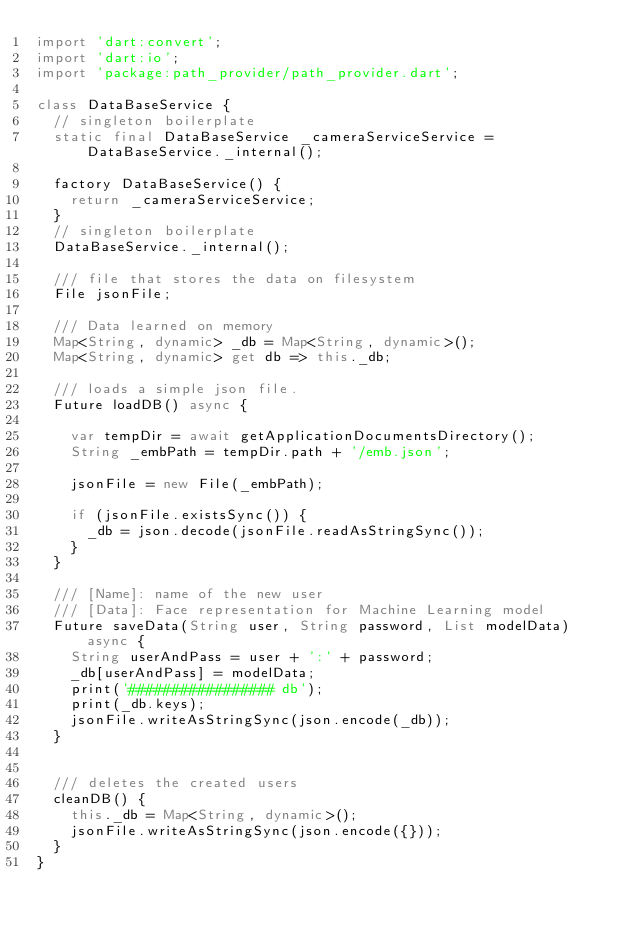<code> <loc_0><loc_0><loc_500><loc_500><_Dart_>import 'dart:convert';
import 'dart:io';
import 'package:path_provider/path_provider.dart';

class DataBaseService {
  // singleton boilerplate
  static final DataBaseService _cameraServiceService = DataBaseService._internal();

  factory DataBaseService() {
    return _cameraServiceService;
  }
  // singleton boilerplate
  DataBaseService._internal();

  /// file that stores the data on filesystem
  File jsonFile;

  /// Data learned on memory
  Map<String, dynamic> _db = Map<String, dynamic>();
  Map<String, dynamic> get db => this._db;

  /// loads a simple json file.
  Future loadDB() async {

    var tempDir = await getApplicationDocumentsDirectory();
    String _embPath = tempDir.path + '/emb.json';

    jsonFile = new File(_embPath);

    if (jsonFile.existsSync()) {
      _db = json.decode(jsonFile.readAsStringSync());
    }
  }

  /// [Name]: name of the new user
  /// [Data]: Face representation for Machine Learning model
  Future saveData(String user, String password, List modelData) async {
    String userAndPass = user + ':' + password;
    _db[userAndPass] = modelData;
    print('################# db');
    print(_db.keys);
    jsonFile.writeAsStringSync(json.encode(_db));
  }


  /// deletes the created users
  cleanDB() {
    this._db = Map<String, dynamic>();
    jsonFile.writeAsStringSync(json.encode({}));
  }
}
</code> 